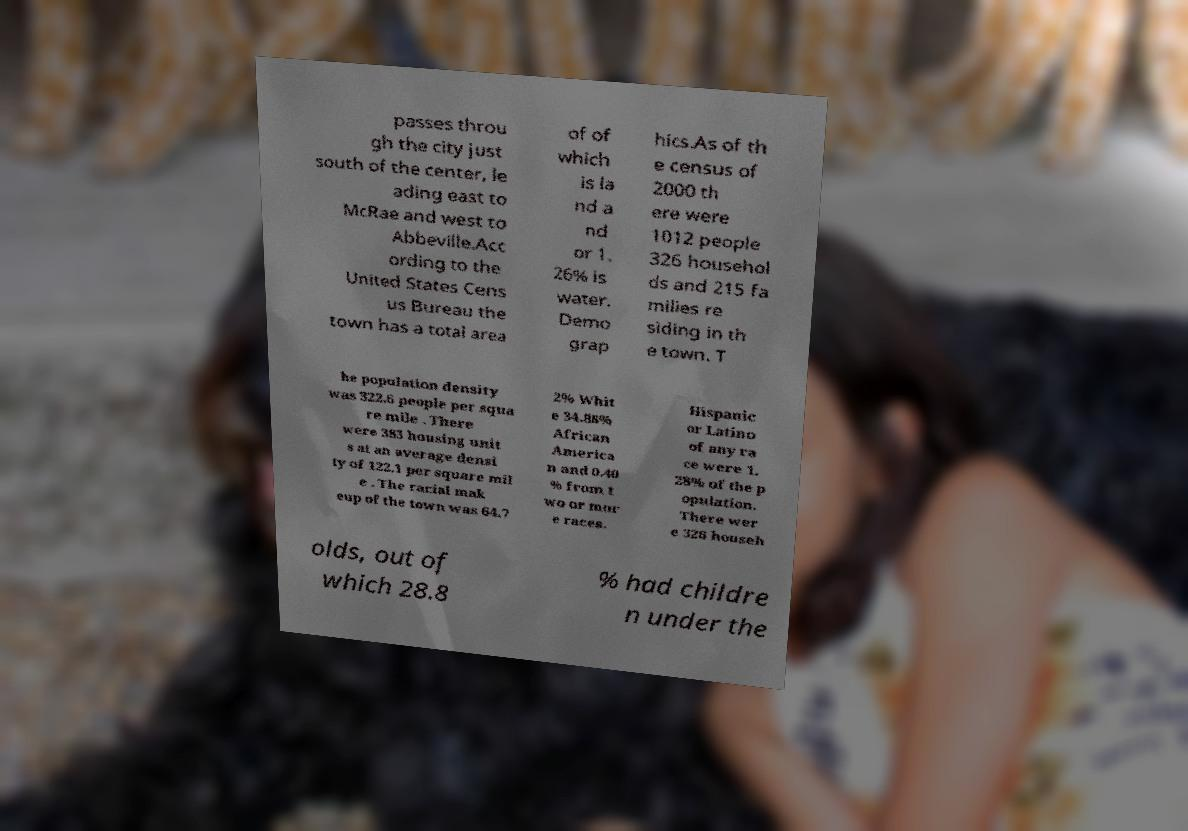What messages or text are displayed in this image? I need them in a readable, typed format. passes throu gh the city just south of the center, le ading east to McRae and west to Abbeville.Acc ording to the United States Cens us Bureau the town has a total area of of which is la nd a nd or 1. 26% is water. Demo grap hics.As of th e census of 2000 th ere were 1012 people 326 househol ds and 215 fa milies re siding in th e town. T he population density was 322.6 people per squa re mile . There were 383 housing unit s at an average densi ty of 122.1 per square mil e . The racial mak eup of the town was 64.7 2% Whit e 34.88% African America n and 0.40 % from t wo or mor e races. Hispanic or Latino of any ra ce were 1. 28% of the p opulation. There wer e 326 househ olds, out of which 28.8 % had childre n under the 